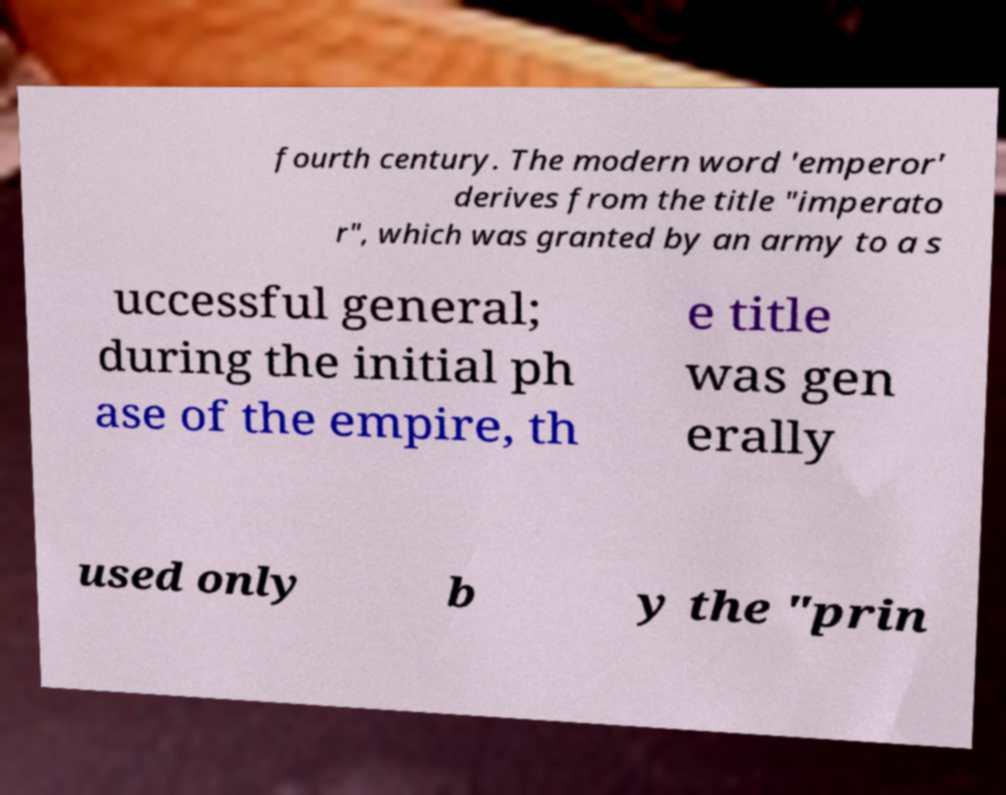What messages or text are displayed in this image? I need them in a readable, typed format. fourth century. The modern word 'emperor' derives from the title "imperato r", which was granted by an army to a s uccessful general; during the initial ph ase of the empire, th e title was gen erally used only b y the "prin 